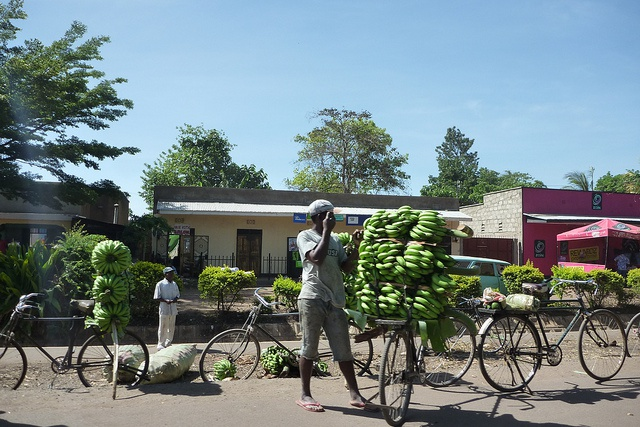Describe the objects in this image and their specific colors. I can see bicycle in lightblue, black, darkgray, and gray tones, people in lightblue, black, gray, darkgray, and lightgray tones, bicycle in lightblue, black, darkgray, and gray tones, bicycle in lightblue, black, darkgray, gray, and beige tones, and bicycle in lightblue, black, darkgray, and gray tones in this image. 